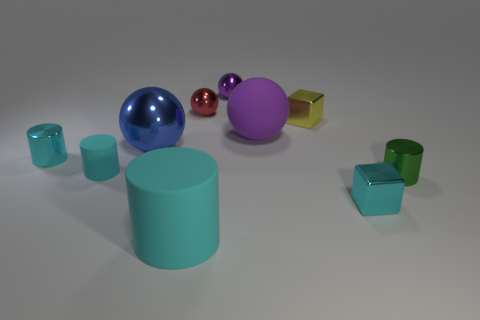Subtract all cyan cylinders. How many were subtracted if there are1cyan cylinders left? 2 Subtract all purple spheres. How many cyan cylinders are left? 3 Subtract all blocks. How many objects are left? 8 Subtract 1 yellow blocks. How many objects are left? 9 Subtract all purple rubber balls. Subtract all small cylinders. How many objects are left? 6 Add 9 large blue metal balls. How many large blue metal balls are left? 10 Add 9 large yellow metallic things. How many large yellow metallic things exist? 9 